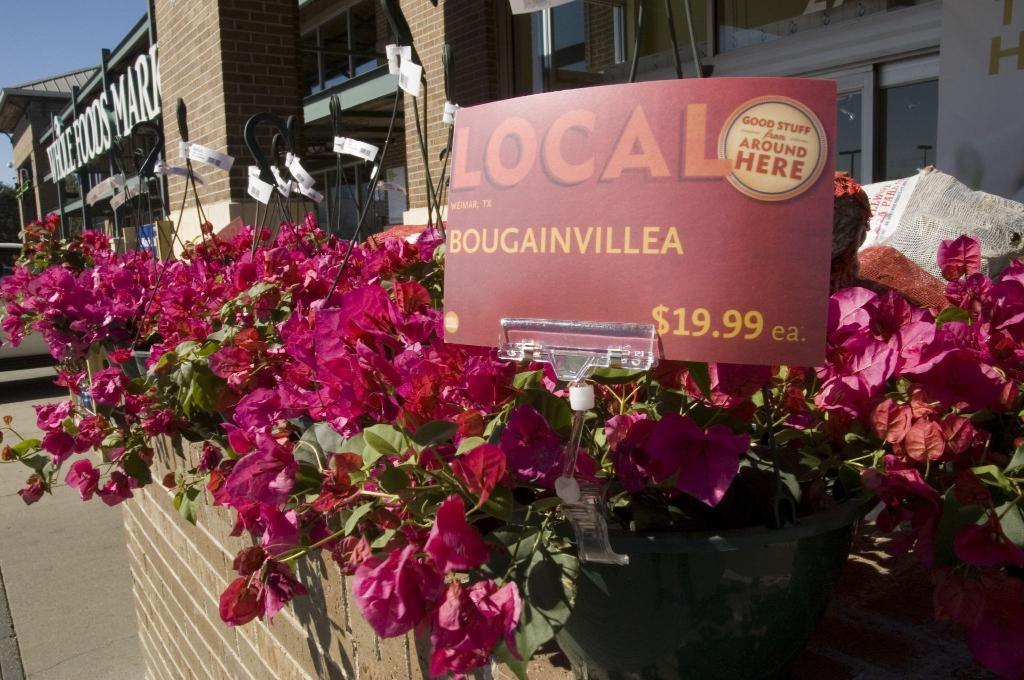What type of flowers are present in the image? There are pink flowers in the image. What else can be seen in the image besides the flowers? There is a paper voucher in the image. What is visible in the background of the image? There is a building and a glass window in the background of the image. Where is the crown located in the image? There is no crown present in the image. 